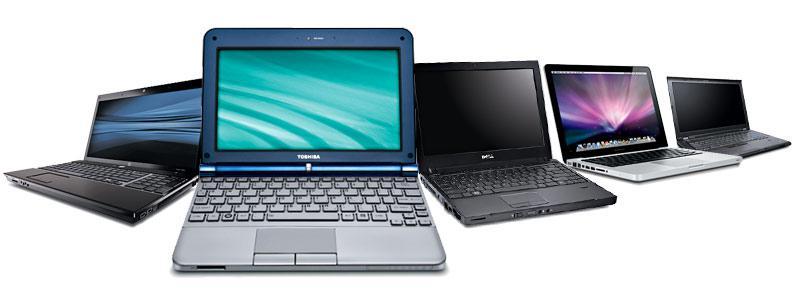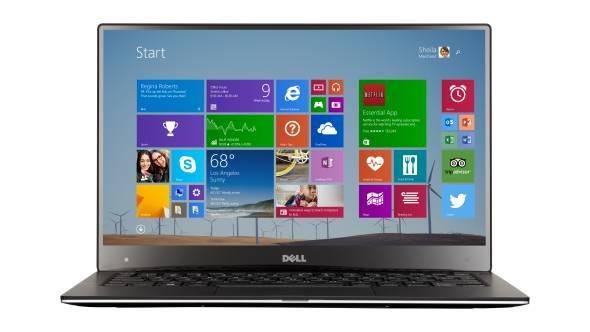The first image is the image on the left, the second image is the image on the right. Examine the images to the left and right. Is the description "There are more laptop-type devices in the right image than in the left." accurate? Answer yes or no. No. The first image is the image on the left, the second image is the image on the right. Given the left and right images, does the statement "All the screens in the image on the right are turned off." hold true? Answer yes or no. No. 